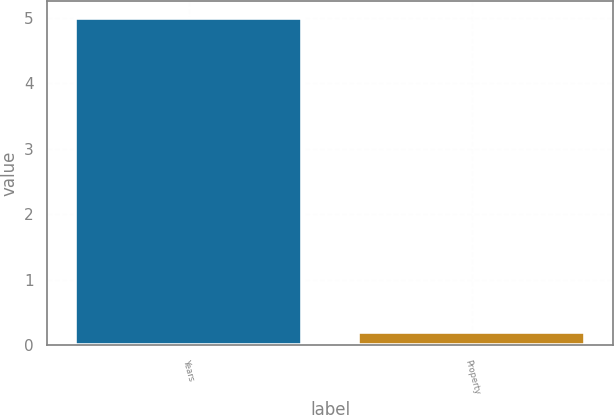<chart> <loc_0><loc_0><loc_500><loc_500><bar_chart><fcel>Years<fcel>Property<nl><fcel>5<fcel>0.2<nl></chart> 